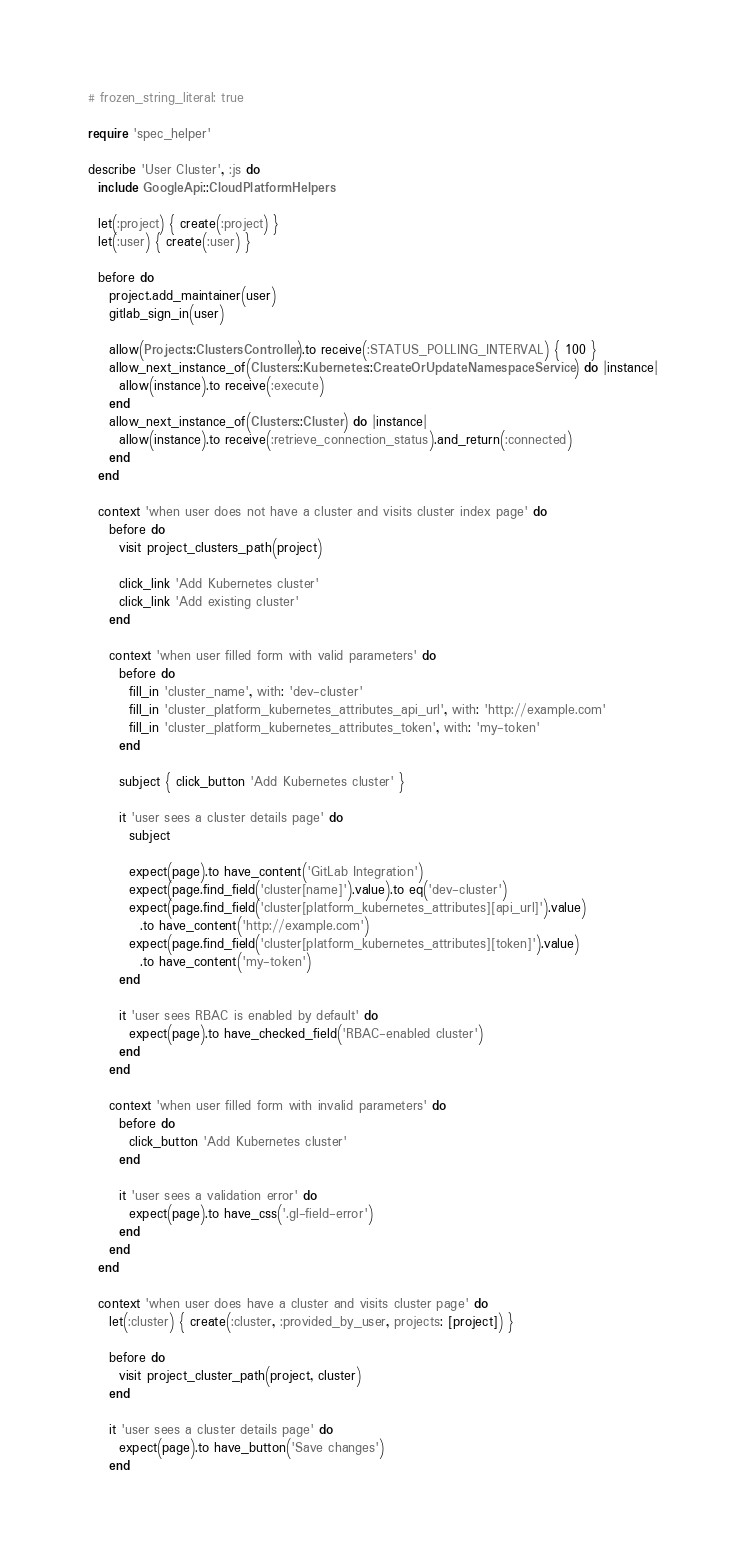<code> <loc_0><loc_0><loc_500><loc_500><_Ruby_># frozen_string_literal: true

require 'spec_helper'

describe 'User Cluster', :js do
  include GoogleApi::CloudPlatformHelpers

  let(:project) { create(:project) }
  let(:user) { create(:user) }

  before do
    project.add_maintainer(user)
    gitlab_sign_in(user)

    allow(Projects::ClustersController).to receive(:STATUS_POLLING_INTERVAL) { 100 }
    allow_next_instance_of(Clusters::Kubernetes::CreateOrUpdateNamespaceService) do |instance|
      allow(instance).to receive(:execute)
    end
    allow_next_instance_of(Clusters::Cluster) do |instance|
      allow(instance).to receive(:retrieve_connection_status).and_return(:connected)
    end
  end

  context 'when user does not have a cluster and visits cluster index page' do
    before do
      visit project_clusters_path(project)

      click_link 'Add Kubernetes cluster'
      click_link 'Add existing cluster'
    end

    context 'when user filled form with valid parameters' do
      before do
        fill_in 'cluster_name', with: 'dev-cluster'
        fill_in 'cluster_platform_kubernetes_attributes_api_url', with: 'http://example.com'
        fill_in 'cluster_platform_kubernetes_attributes_token', with: 'my-token'
      end

      subject { click_button 'Add Kubernetes cluster' }

      it 'user sees a cluster details page' do
        subject

        expect(page).to have_content('GitLab Integration')
        expect(page.find_field('cluster[name]').value).to eq('dev-cluster')
        expect(page.find_field('cluster[platform_kubernetes_attributes][api_url]').value)
          .to have_content('http://example.com')
        expect(page.find_field('cluster[platform_kubernetes_attributes][token]').value)
          .to have_content('my-token')
      end

      it 'user sees RBAC is enabled by default' do
        expect(page).to have_checked_field('RBAC-enabled cluster')
      end
    end

    context 'when user filled form with invalid parameters' do
      before do
        click_button 'Add Kubernetes cluster'
      end

      it 'user sees a validation error' do
        expect(page).to have_css('.gl-field-error')
      end
    end
  end

  context 'when user does have a cluster and visits cluster page' do
    let(:cluster) { create(:cluster, :provided_by_user, projects: [project]) }

    before do
      visit project_cluster_path(project, cluster)
    end

    it 'user sees a cluster details page' do
      expect(page).to have_button('Save changes')
    end
</code> 